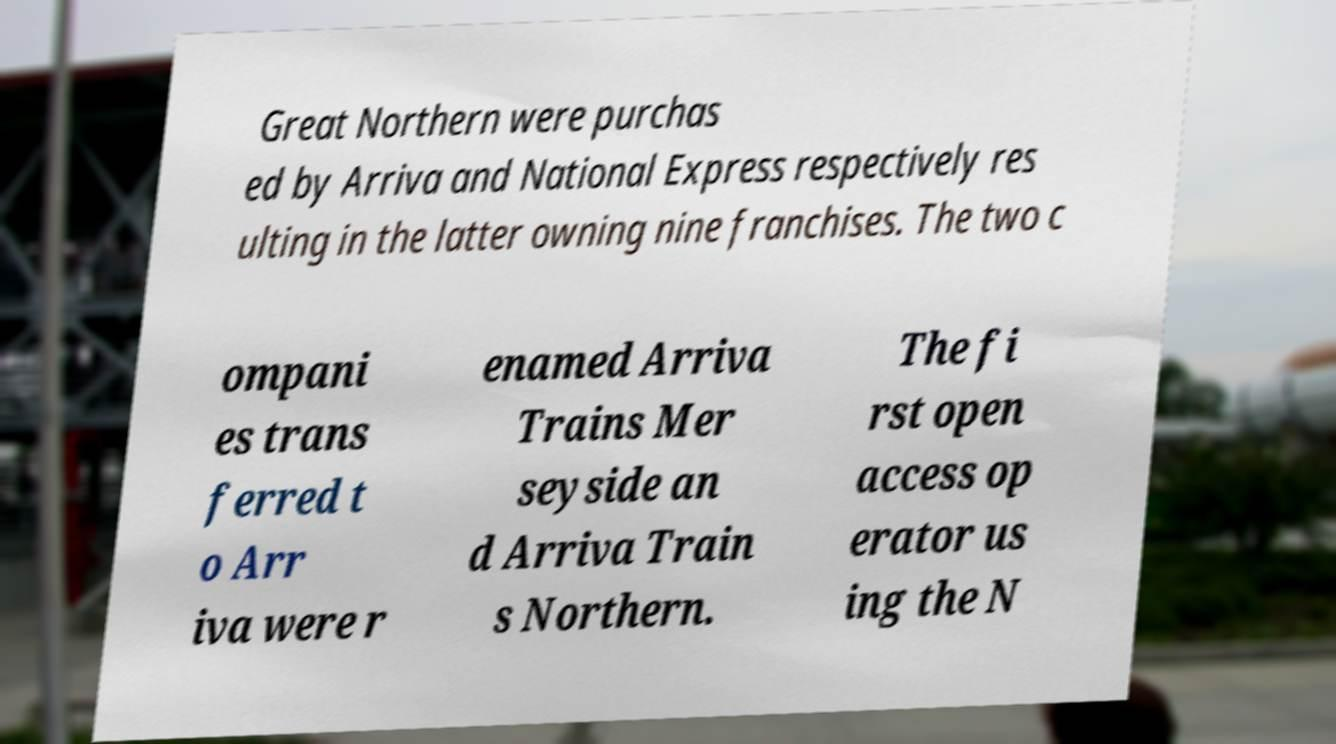Could you extract and type out the text from this image? Great Northern were purchas ed by Arriva and National Express respectively res ulting in the latter owning nine franchises. The two c ompani es trans ferred t o Arr iva were r enamed Arriva Trains Mer seyside an d Arriva Train s Northern. The fi rst open access op erator us ing the N 